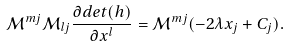<formula> <loc_0><loc_0><loc_500><loc_500>\mathcal { M } ^ { m j } \mathcal { M } _ { l j } \frac { \partial d e t ( h ) } { \partial x ^ { l } } = \mathcal { M } ^ { m j } ( - 2 \lambda x _ { j } + C _ { j } ) .</formula> 